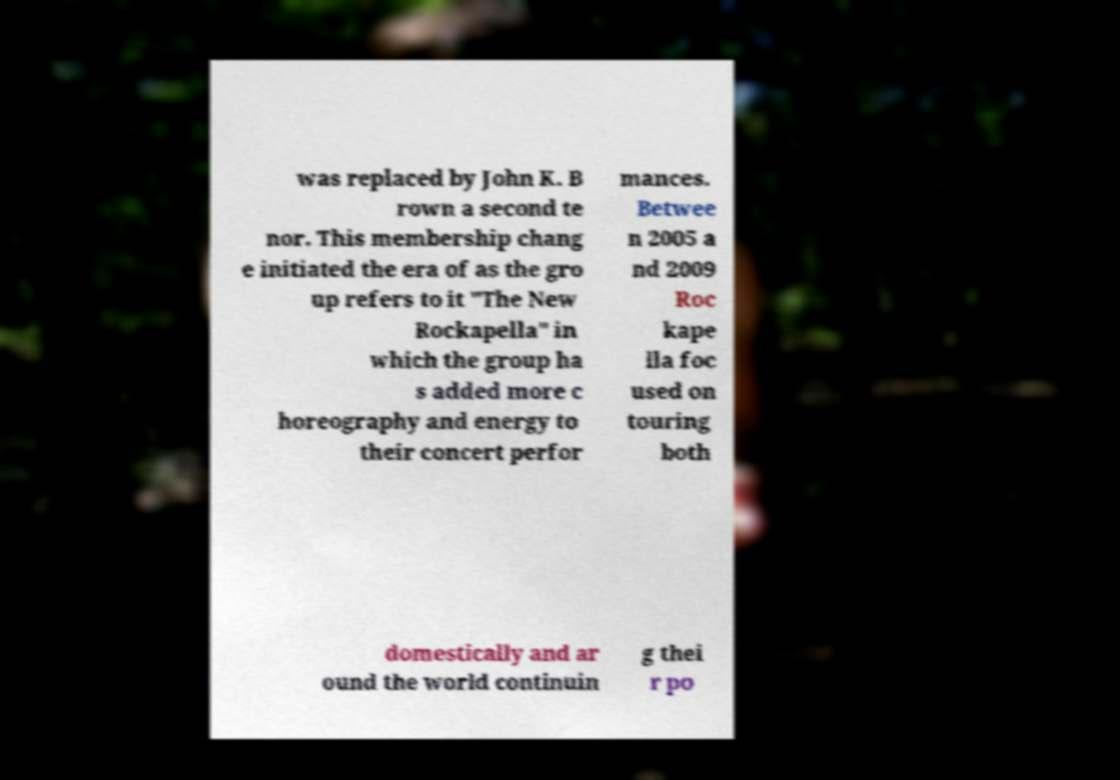Can you read and provide the text displayed in the image?This photo seems to have some interesting text. Can you extract and type it out for me? was replaced by John K. B rown a second te nor. This membership chang e initiated the era of as the gro up refers to it "The New Rockapella" in which the group ha s added more c horeography and energy to their concert perfor mances. Betwee n 2005 a nd 2009 Roc kape lla foc used on touring both domestically and ar ound the world continuin g thei r po 